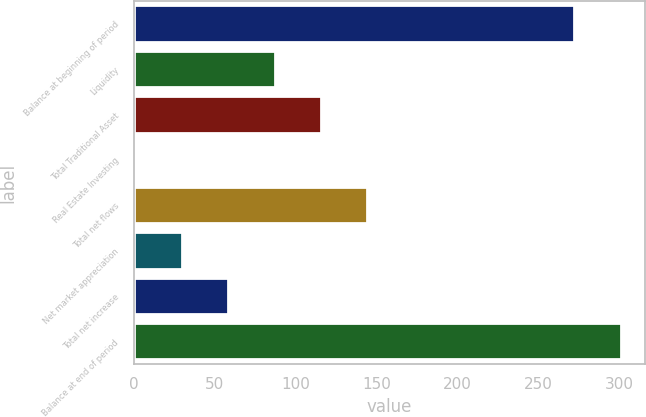Convert chart. <chart><loc_0><loc_0><loc_500><loc_500><bar_chart><fcel>Balance at beginning of period<fcel>Liquidity<fcel>Total Traditional Asset<fcel>Real Estate Investing<fcel>Total net flows<fcel>Net market appreciation<fcel>Total net increase<fcel>Balance at end of period<nl><fcel>272<fcel>86.8<fcel>115.4<fcel>1<fcel>144<fcel>29.6<fcel>58.2<fcel>300.6<nl></chart> 